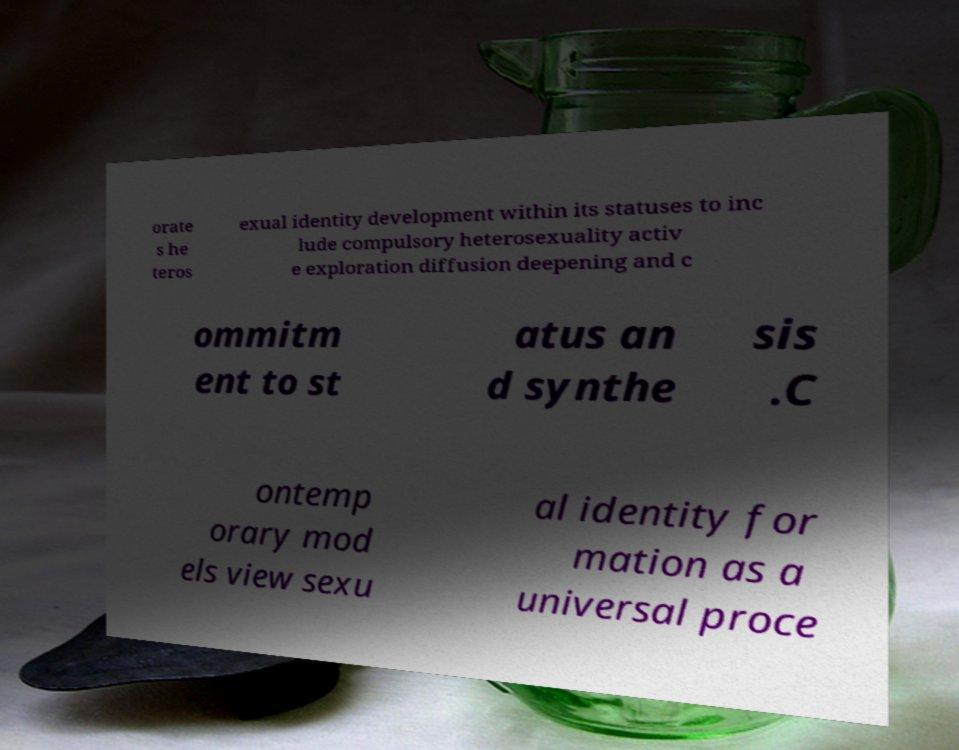Please identify and transcribe the text found in this image. orate s he teros exual identity development within its statuses to inc lude compulsory heterosexuality activ e exploration diffusion deepening and c ommitm ent to st atus an d synthe sis .C ontemp orary mod els view sexu al identity for mation as a universal proce 